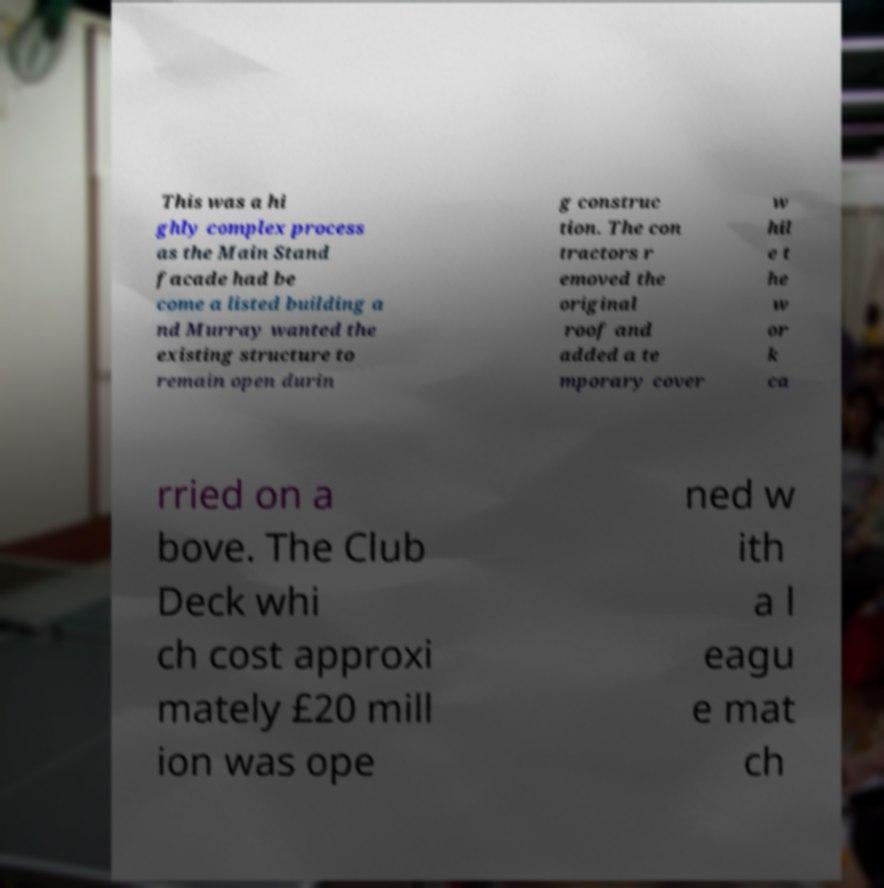Could you assist in decoding the text presented in this image and type it out clearly? This was a hi ghly complex process as the Main Stand facade had be come a listed building a nd Murray wanted the existing structure to remain open durin g construc tion. The con tractors r emoved the original roof and added a te mporary cover w hil e t he w or k ca rried on a bove. The Club Deck whi ch cost approxi mately £20 mill ion was ope ned w ith a l eagu e mat ch 